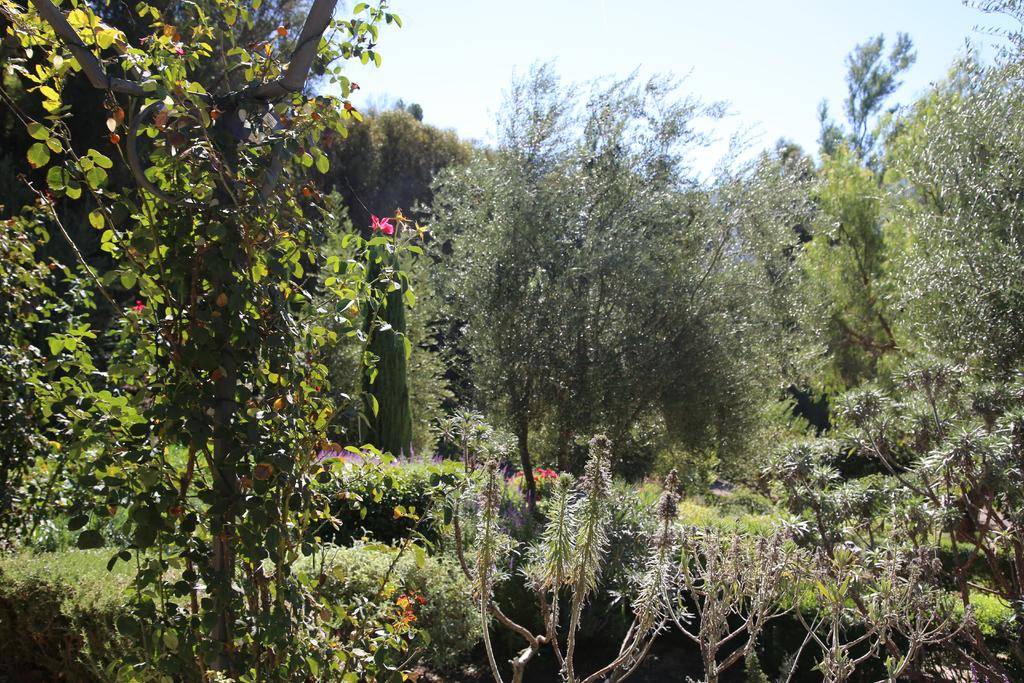What color are the flowers on the plants in the image? The flowers on the plants in the image are red. What can be seen in the background of the image? There are many trees, plants, and grass in the background of the image. What is visible at the top of the image? The sky is visible at the top of the image. What can be observed in the sky? Clouds are present in the sky. How many women are present in the image? There are no women present in the image; it features plants, trees, grass, and the sky. What type of ship can be seen sailing in the background of the image? There is no ship present in the image; it features plants, trees, grass, and the sky. 